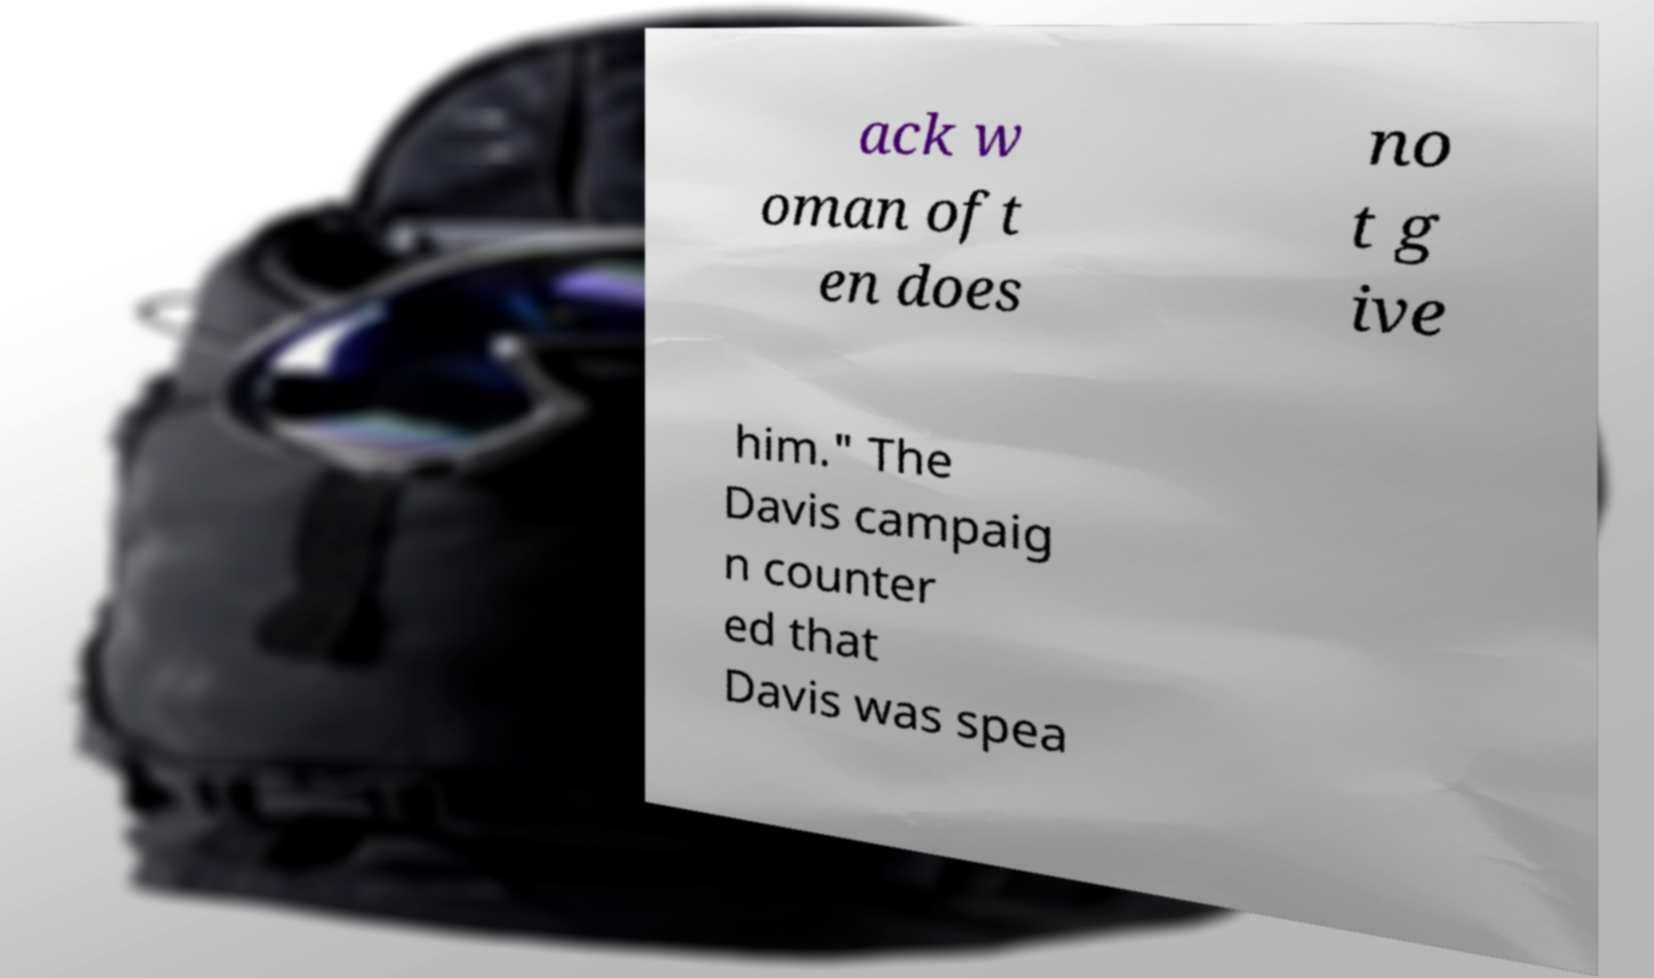Can you accurately transcribe the text from the provided image for me? ack w oman oft en does no t g ive him." The Davis campaig n counter ed that Davis was spea 